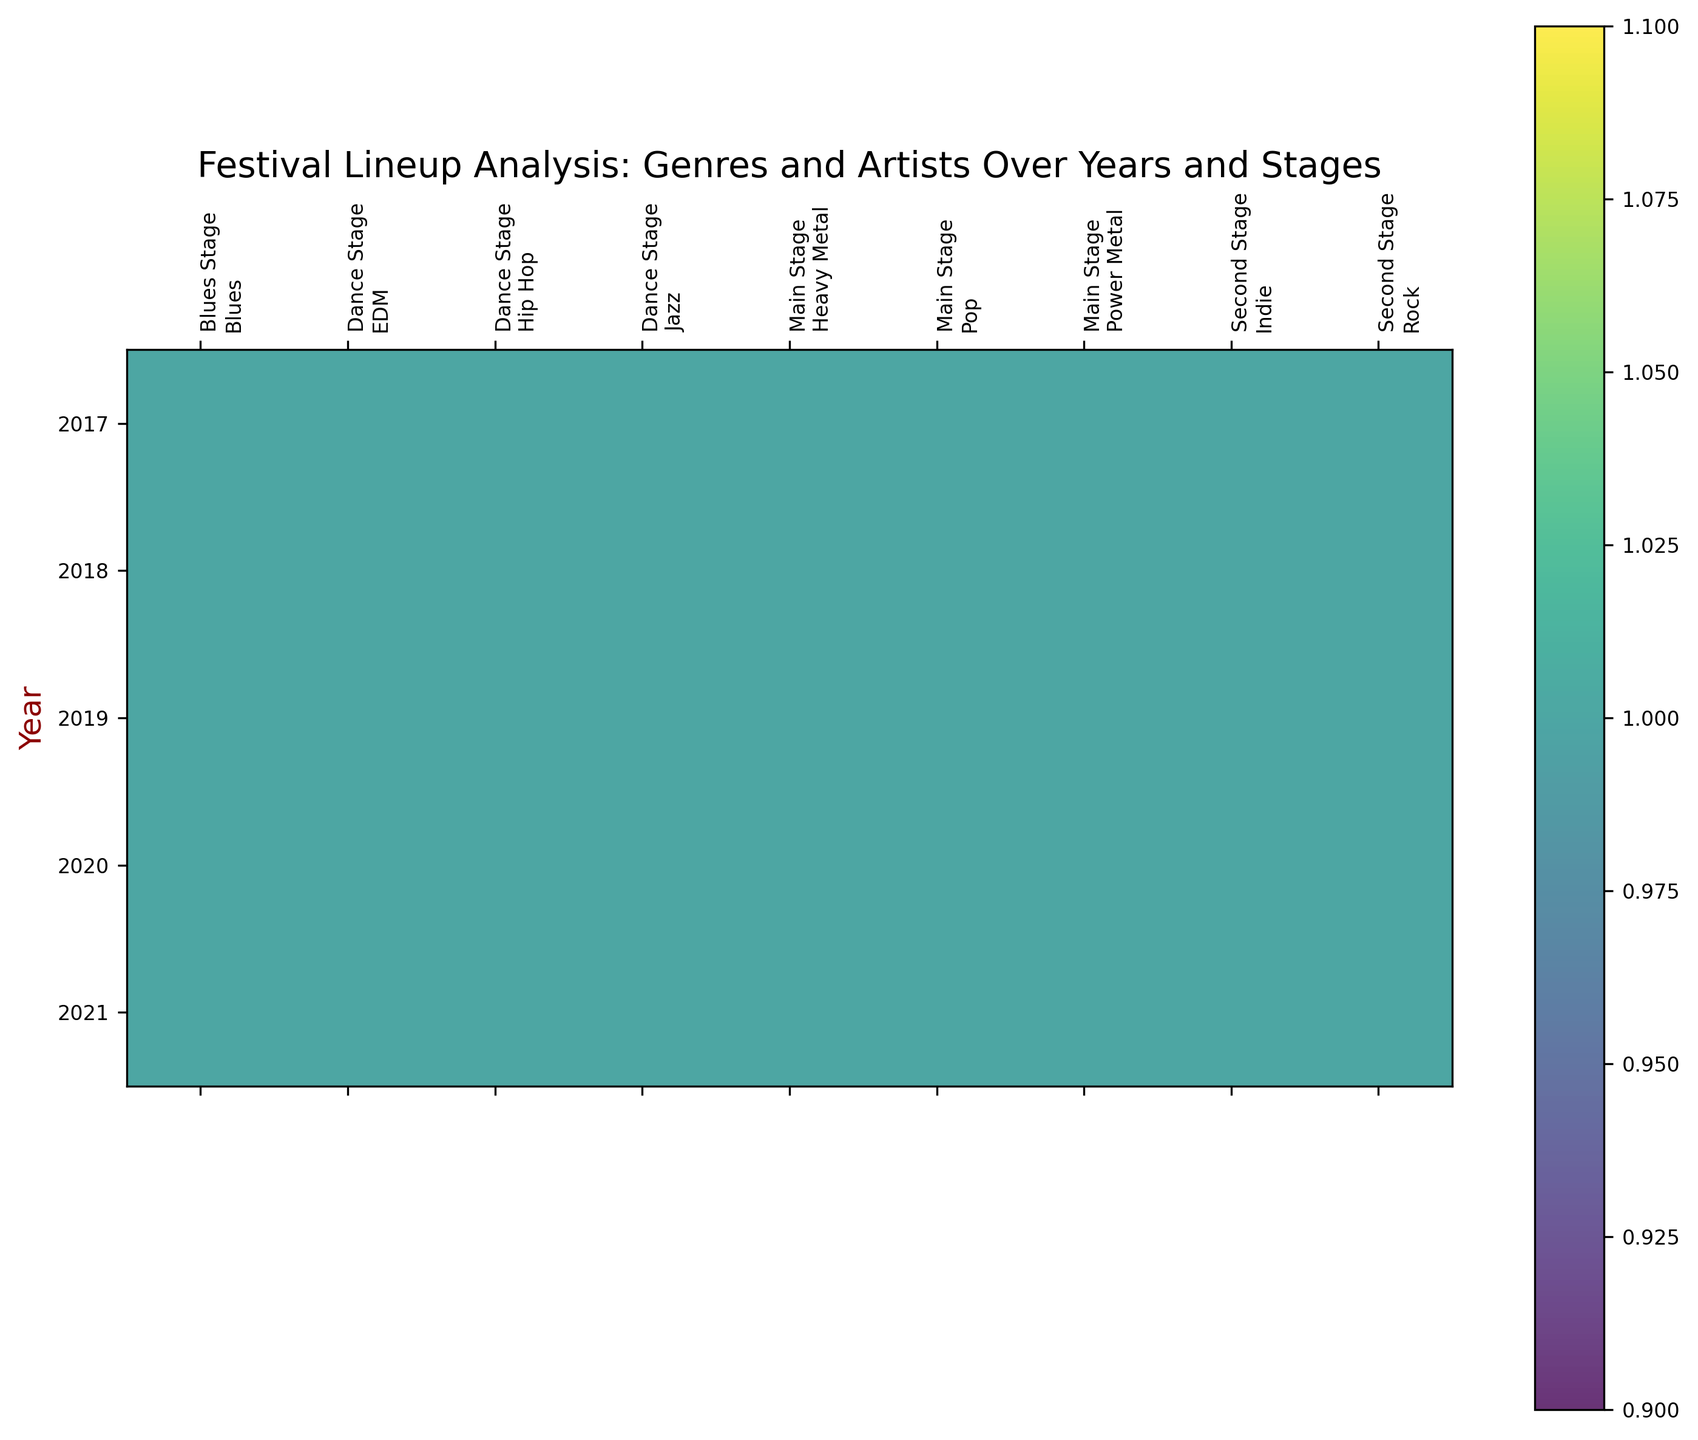Which genres are consistently present on the Main Stage from 2017 to 2021? All the cells under the Main Stage for every year from 2017 to 2021 should be checked. Genres with presence marked '1' every year are consistently present.
Answer: Power Metal, Heavy Metal, Pop How many times did Helloween perform on the Main Stage from 2017 to 2021? Each cell corresponding to Helloween on the Main Stage across the years 2017 to 2021 should be summed. Each presence marked '1' indicates a performance.
Answer: 5 Which stage has the most diverse set of genres over the years? Identify which stage has the highest number of different genres represented. Count the unique genres for each stage across all years.
Answer: Dance Stage Is there any genre that is present on the Main Stage every year from 2017 to 2021 apart from Power Metal and Heavy Metal? Check each genre under the Main Stage for every year from 2017 to 2021. Genres present every year will have continuous presence marked '1'.
Answer: Pop Which genre has the highest presence on the Second Stage across all the years? Sum the presence values for each genre on the Second Stage from 2017 to 2021 and compare the totals.
Answer: Rock Do any genres appear exclusively on one stage? If yes, which ones? Examine each genre's presence on different stages across the years. Identify any genres that are present on only one specific stage throughout.
Answer: Blues (Blues Stage) How does the presence of Power Metal compare between Main Stage and other stages? Examine the presence of Power Metal on the Main Stage versus other stages over the years. Presence on the Main Stage should be 5, and 0 on other stages if none are found there.
Answer: Main Stage: 5, Other stages: 0 Which genre has the least presence on the Dance Stage from 2017 to 2021? Calculate the total presence for each genre on the Dance Stage by summing the presence values from 2017 to 2021. The genre with the smallest total has the least presence.
Answer: Jazz Is the presence of artists from the Jazz genre continuous on the Dance Stage from 2017 to 2021? Check if the Jazz genre has presence marked '1' for every year from 2017 to 2021 on the Dance Stage.
Answer: Yes 